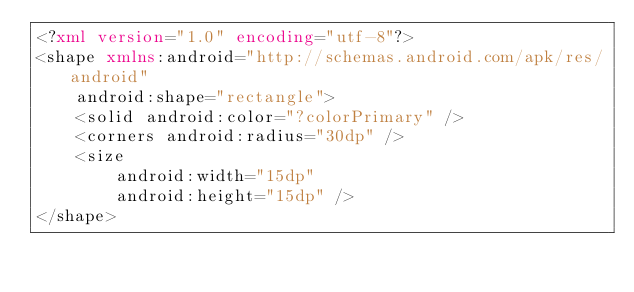<code> <loc_0><loc_0><loc_500><loc_500><_XML_><?xml version="1.0" encoding="utf-8"?>
<shape xmlns:android="http://schemas.android.com/apk/res/android"
    android:shape="rectangle">
    <solid android:color="?colorPrimary" />
    <corners android:radius="30dp" />
    <size
        android:width="15dp"
        android:height="15dp" />
</shape></code> 